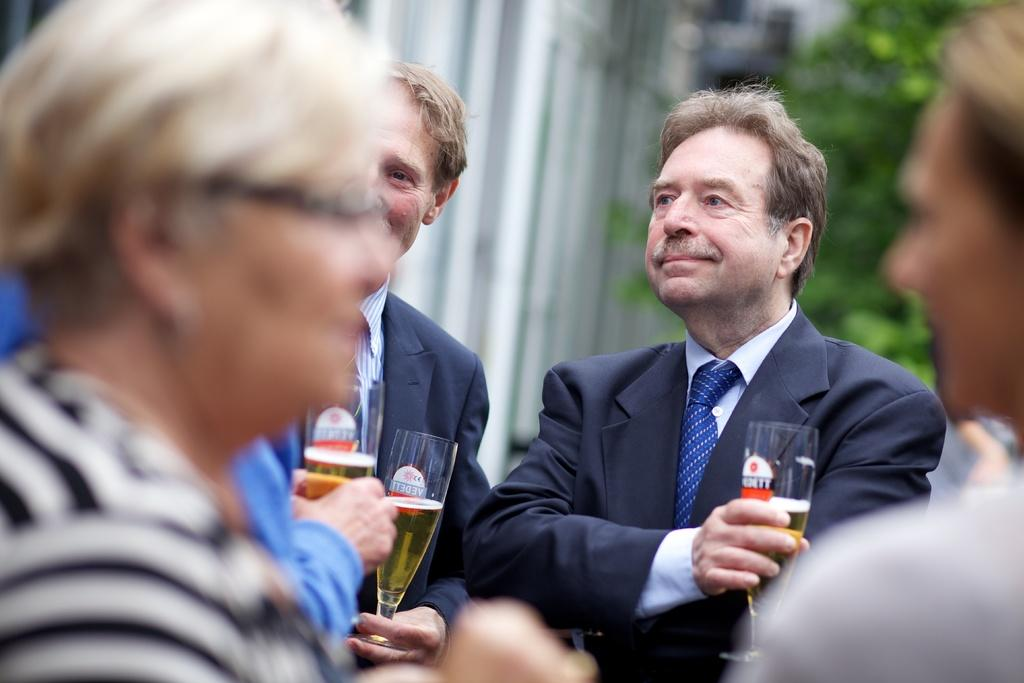How many people are present in the image? There are four people in the image. Can you describe the appearance of the people in the image? Two of the people are blurred, while the other two are wearing blue suits. What are the two people in blue suits holding? The two people in blue suits are holding glasses. What can be seen in the background of the image? There is a tree visible in the background of the image. What type of kitten can be seen breathing heavily in the image? There is no kitten present in the image, and therefore no such activity can be observed. 